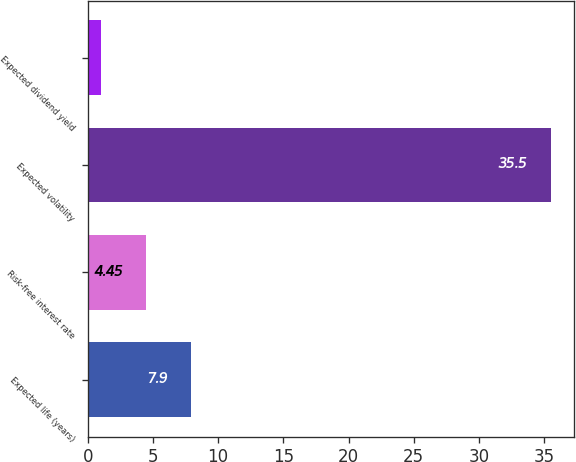Convert chart. <chart><loc_0><loc_0><loc_500><loc_500><bar_chart><fcel>Expected life (years)<fcel>Risk-free interest rate<fcel>Expected volatility<fcel>Expected dividend yield<nl><fcel>7.9<fcel>4.45<fcel>35.5<fcel>1<nl></chart> 